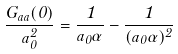Convert formula to latex. <formula><loc_0><loc_0><loc_500><loc_500>\frac { G _ { a a } ( 0 ) } { a ^ { 2 } _ { 0 } } = \frac { 1 } { a _ { 0 } \alpha } - \frac { 1 } { ( a _ { 0 } \alpha ) ^ { 2 } }</formula> 